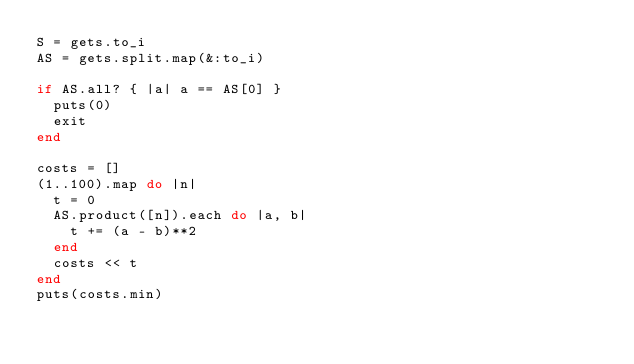Convert code to text. <code><loc_0><loc_0><loc_500><loc_500><_Ruby_>S = gets.to_i
AS = gets.split.map(&:to_i)

if AS.all? { |a| a == AS[0] }
  puts(0)
  exit
end

costs = []
(1..100).map do |n|
  t = 0
  AS.product([n]).each do |a, b|
    t += (a - b)**2
  end
  costs << t
end
puts(costs.min)</code> 